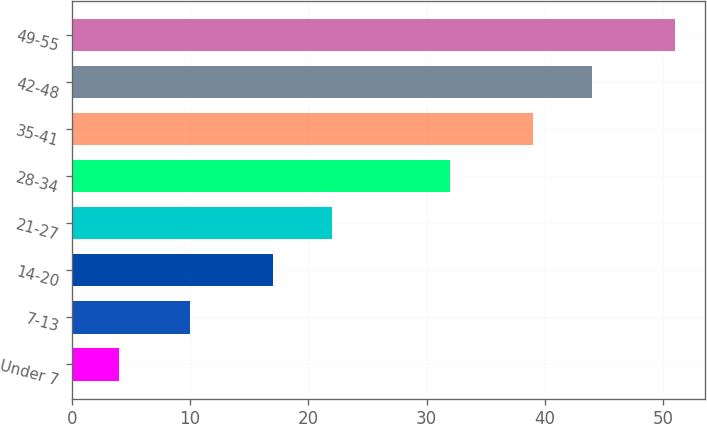<chart> <loc_0><loc_0><loc_500><loc_500><bar_chart><fcel>Under 7<fcel>7-13<fcel>14-20<fcel>21-27<fcel>28-34<fcel>35-41<fcel>42-48<fcel>49-55<nl><fcel>4<fcel>10<fcel>17<fcel>22<fcel>32<fcel>39<fcel>44<fcel>51<nl></chart> 